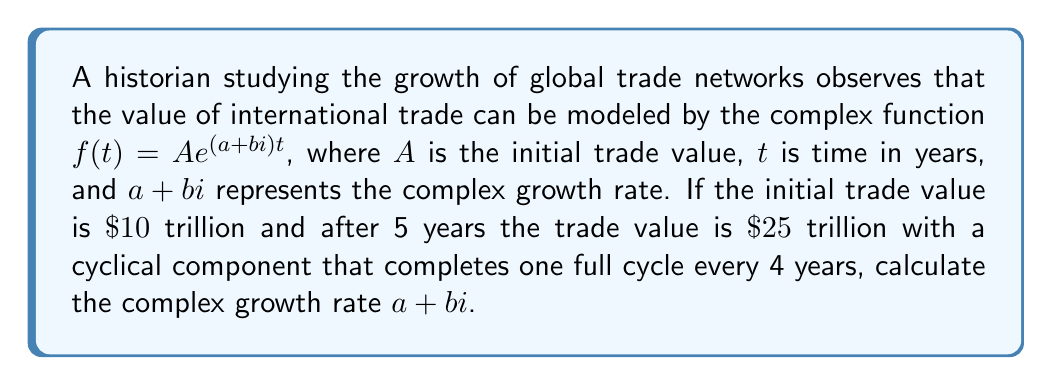Provide a solution to this math problem. Let's approach this step-by-step:

1) We're given that $f(t) = Ae^{(a+bi)t}$, where $A = 10$ trillion and $f(5) = 25$ trillion.

2) Substituting these values:
   $25 = 10e^{(a+bi)5}$

3) Dividing both sides by 10:
   $2.5 = e^{(a+bi)5}$

4) Taking the natural logarithm of both sides:
   $\ln(2.5) = (a+bi)5$

5) $\ln(2.5) \approx 0.9163$

6) Dividing both sides by 5:
   $0.1833 = a+bi$

7) We know that the cyclical component completes one full cycle every 4 years. This means the imaginary part $b$ must satisfy:
   $4b = 2\pi$
   $b = \frac{\pi}{2} \approx 1.5708$

8) Now we can find $a$:
   $a = 0.1833 - 1.5708i$

Therefore, the complex growth rate is $a+bi = 0.1833 + 1.5708i$.
Answer: $0.1833 + 1.5708i$ 